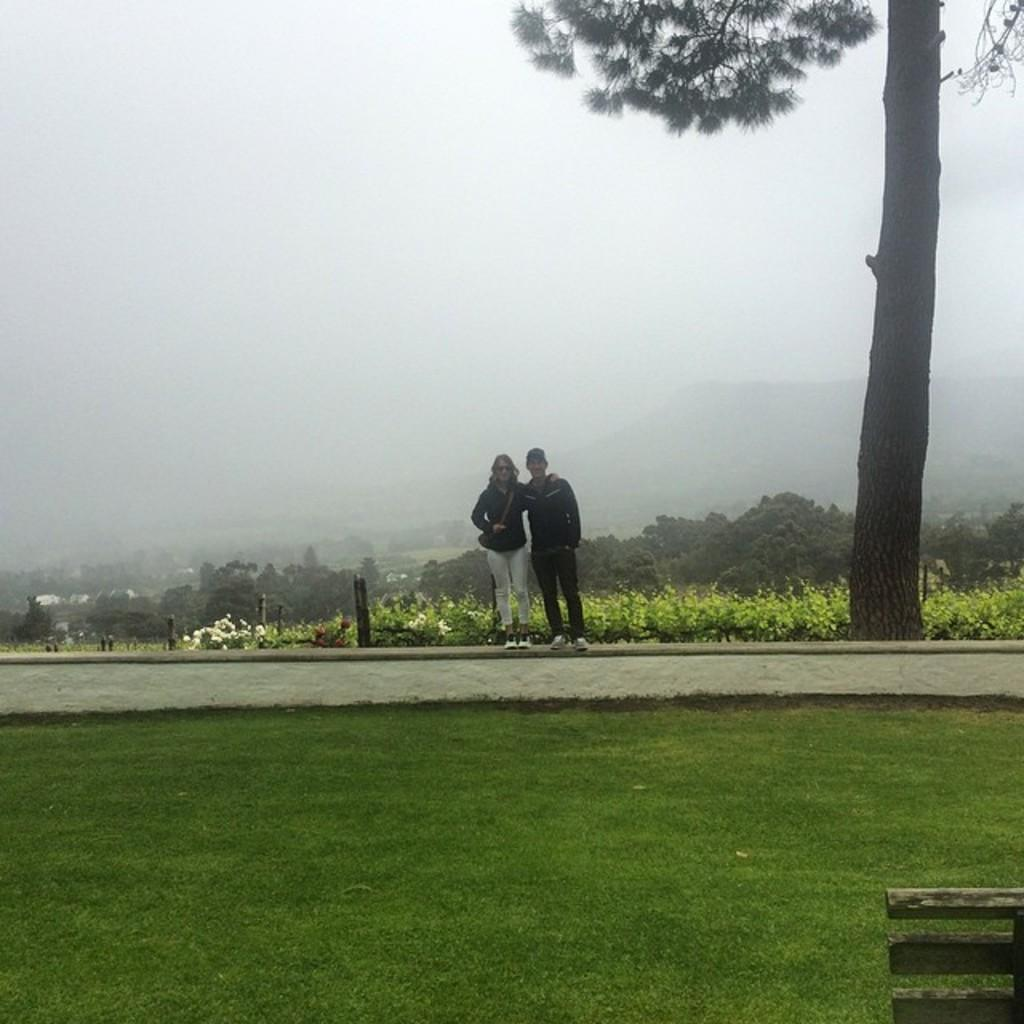Who are the people in the image? There is a man and a woman in the image. Where are the man and woman standing? They are standing on a walkway. What can be seen in the background of the image? There is a hill, a tree, and many plants in the background of the image. What is the condition of the sky in the image? The sky is full of clouds. What type of wine is the man holding in the image? There is no wine present in the image; the man and woman are not holding any wine. What sack is the woman carrying on her vacation in the image? There is no mention of a vacation or a sack in the image; the focus is on the man and woman standing on a walkway with a hill, a tree, and many plants in the background. 